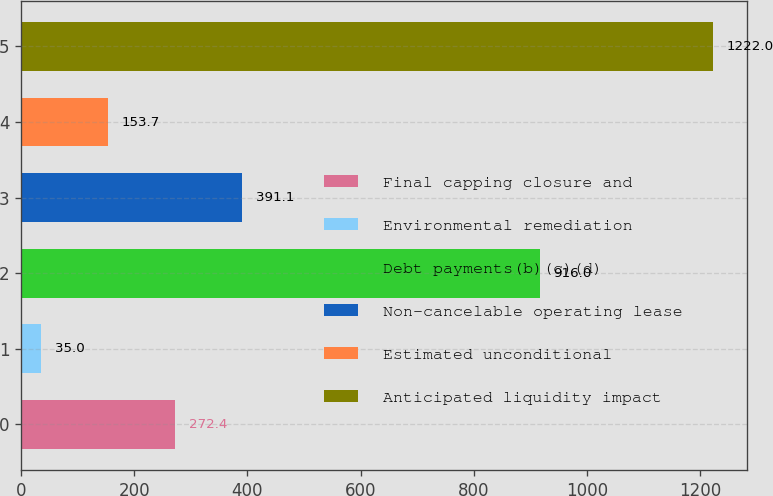Convert chart to OTSL. <chart><loc_0><loc_0><loc_500><loc_500><bar_chart><fcel>Final capping closure and<fcel>Environmental remediation<fcel>Debt payments(b)(c)(d)<fcel>Non-cancelable operating lease<fcel>Estimated unconditional<fcel>Anticipated liquidity impact<nl><fcel>272.4<fcel>35<fcel>916<fcel>391.1<fcel>153.7<fcel>1222<nl></chart> 